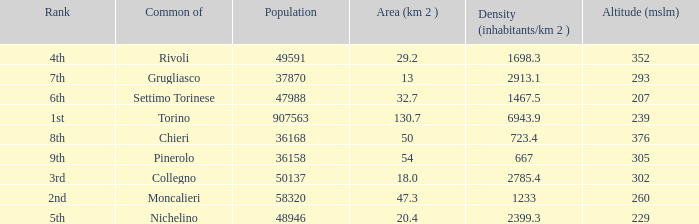What rank is the common with an area of 47.3 km^2? 2nd. Parse the full table. {'header': ['Rank', 'Common of', 'Population', 'Area (km 2 )', 'Density (inhabitants/km 2 )', 'Altitude (mslm)'], 'rows': [['4th', 'Rivoli', '49591', '29.2', '1698.3', '352'], ['7th', 'Grugliasco', '37870', '13', '2913.1', '293'], ['6th', 'Settimo Torinese', '47988', '32.7', '1467.5', '207'], ['1st', 'Torino', '907563', '130.7', '6943.9', '239'], ['8th', 'Chieri', '36168', '50', '723.4', '376'], ['9th', 'Pinerolo', '36158', '54', '667', '305'], ['3rd', 'Collegno', '50137', '18.0', '2785.4', '302'], ['2nd', 'Moncalieri', '58320', '47.3', '1233', '260'], ['5th', 'Nichelino', '48946', '20.4', '2399.3', '229']]} 